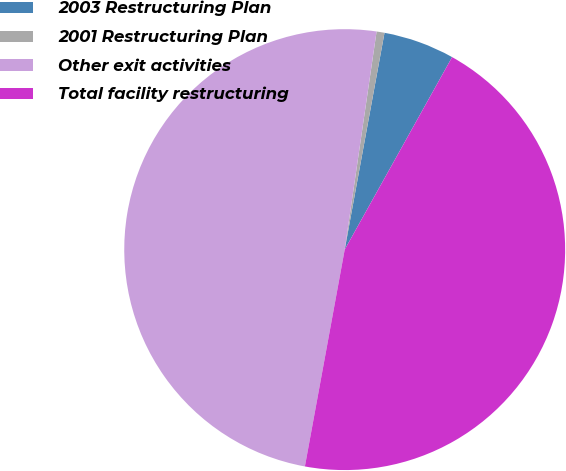<chart> <loc_0><loc_0><loc_500><loc_500><pie_chart><fcel>2003 Restructuring Plan<fcel>2001 Restructuring Plan<fcel>Other exit activities<fcel>Total facility restructuring<nl><fcel>5.21%<fcel>0.58%<fcel>49.42%<fcel>44.79%<nl></chart> 